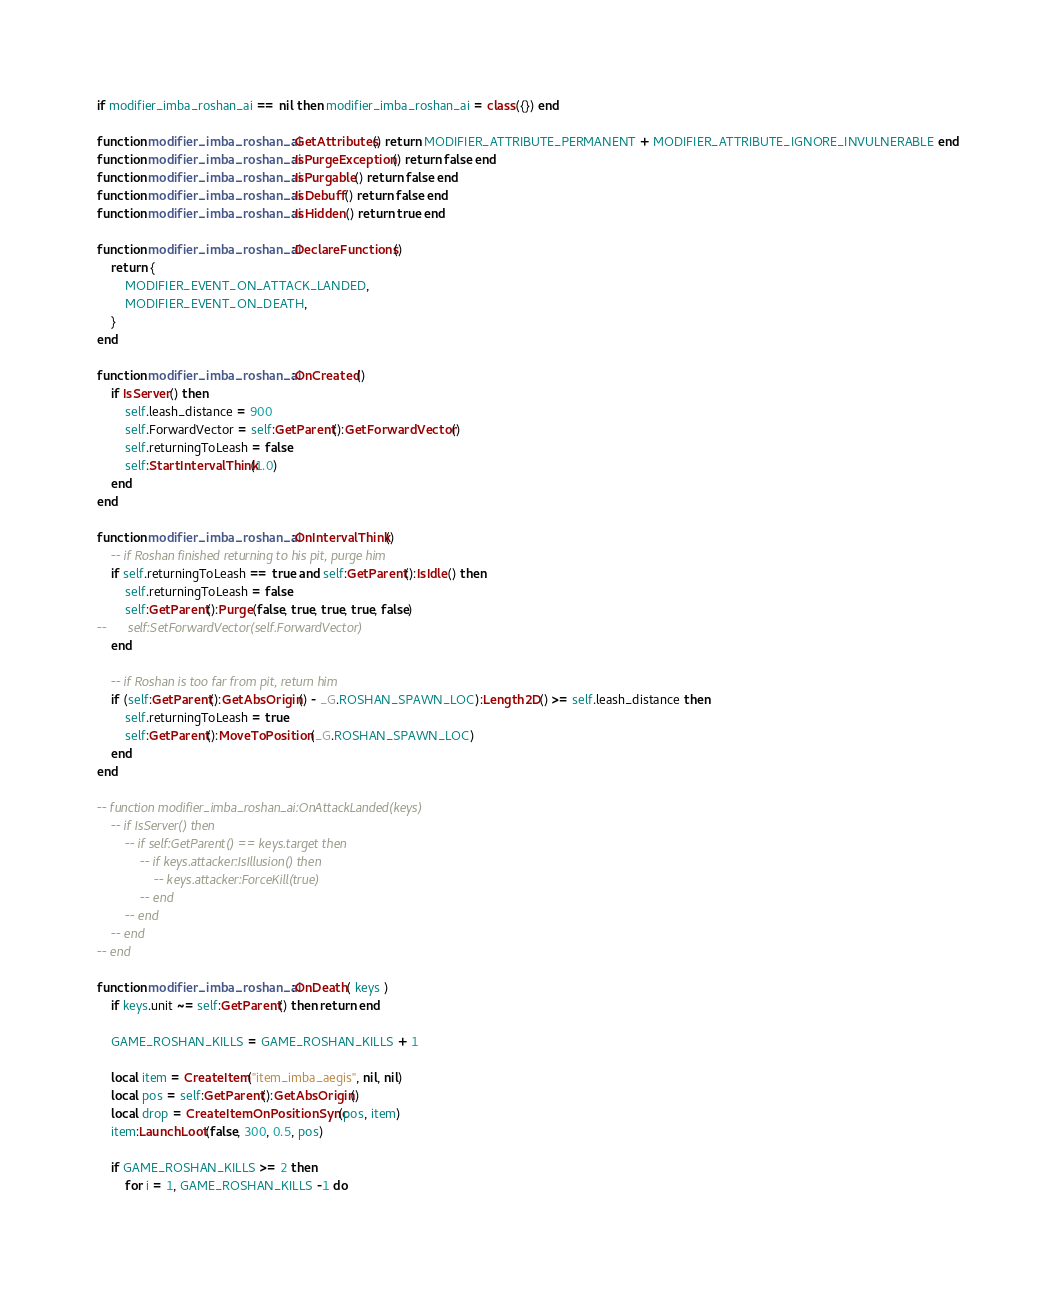<code> <loc_0><loc_0><loc_500><loc_500><_Lua_>if modifier_imba_roshan_ai == nil then modifier_imba_roshan_ai = class({}) end

function modifier_imba_roshan_ai:GetAttributes() return MODIFIER_ATTRIBUTE_PERMANENT + MODIFIER_ATTRIBUTE_IGNORE_INVULNERABLE end
function modifier_imba_roshan_ai:IsPurgeException() return false end
function modifier_imba_roshan_ai:IsPurgable() return false end
function modifier_imba_roshan_ai:IsDebuff() return false end
function modifier_imba_roshan_ai:IsHidden() return true end

function modifier_imba_roshan_ai:DeclareFunctions()
	return {
		MODIFIER_EVENT_ON_ATTACK_LANDED,
		MODIFIER_EVENT_ON_DEATH,
	}
end

function modifier_imba_roshan_ai:OnCreated()
	if IsServer() then
		self.leash_distance = 900
		self.ForwardVector = self:GetParent():GetForwardVector()
		self.returningToLeash = false
		self:StartIntervalThink(1.0)
	end
end

function modifier_imba_roshan_ai:OnIntervalThink()
	-- if Roshan finished returning to his pit, purge him
	if self.returningToLeash == true and self:GetParent():IsIdle() then
		self.returningToLeash = false
		self:GetParent():Purge(false, true, true, true, false)
--		self:SetForwardVector(self.ForwardVector)
	end

	-- if Roshan is too far from pit, return him
	if (self:GetParent():GetAbsOrigin() - _G.ROSHAN_SPAWN_LOC):Length2D() >= self.leash_distance then
		self.returningToLeash = true
		self:GetParent():MoveToPosition(_G.ROSHAN_SPAWN_LOC)
	end
end

-- function modifier_imba_roshan_ai:OnAttackLanded(keys)
	-- if IsServer() then
		-- if self:GetParent() == keys.target then
			-- if keys.attacker:IsIllusion() then
				-- keys.attacker:ForceKill(true)
			-- end
		-- end
	-- end
-- end

function modifier_imba_roshan_ai:OnDeath( keys )
	if keys.unit ~= self:GetParent() then return end

	GAME_ROSHAN_KILLS = GAME_ROSHAN_KILLS + 1

	local item = CreateItem("item_imba_aegis", nil, nil)
	local pos = self:GetParent():GetAbsOrigin()
	local drop = CreateItemOnPositionSync(pos, item)
	item:LaunchLoot(false, 300, 0.5, pos)

	if GAME_ROSHAN_KILLS >= 2 then
		for i = 1, GAME_ROSHAN_KILLS -1 do</code> 